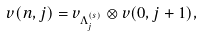<formula> <loc_0><loc_0><loc_500><loc_500>v ( n , j ) = v _ { \Lambda _ { j } ^ { ( s ) } } \otimes v ( 0 , j + 1 ) ,</formula> 